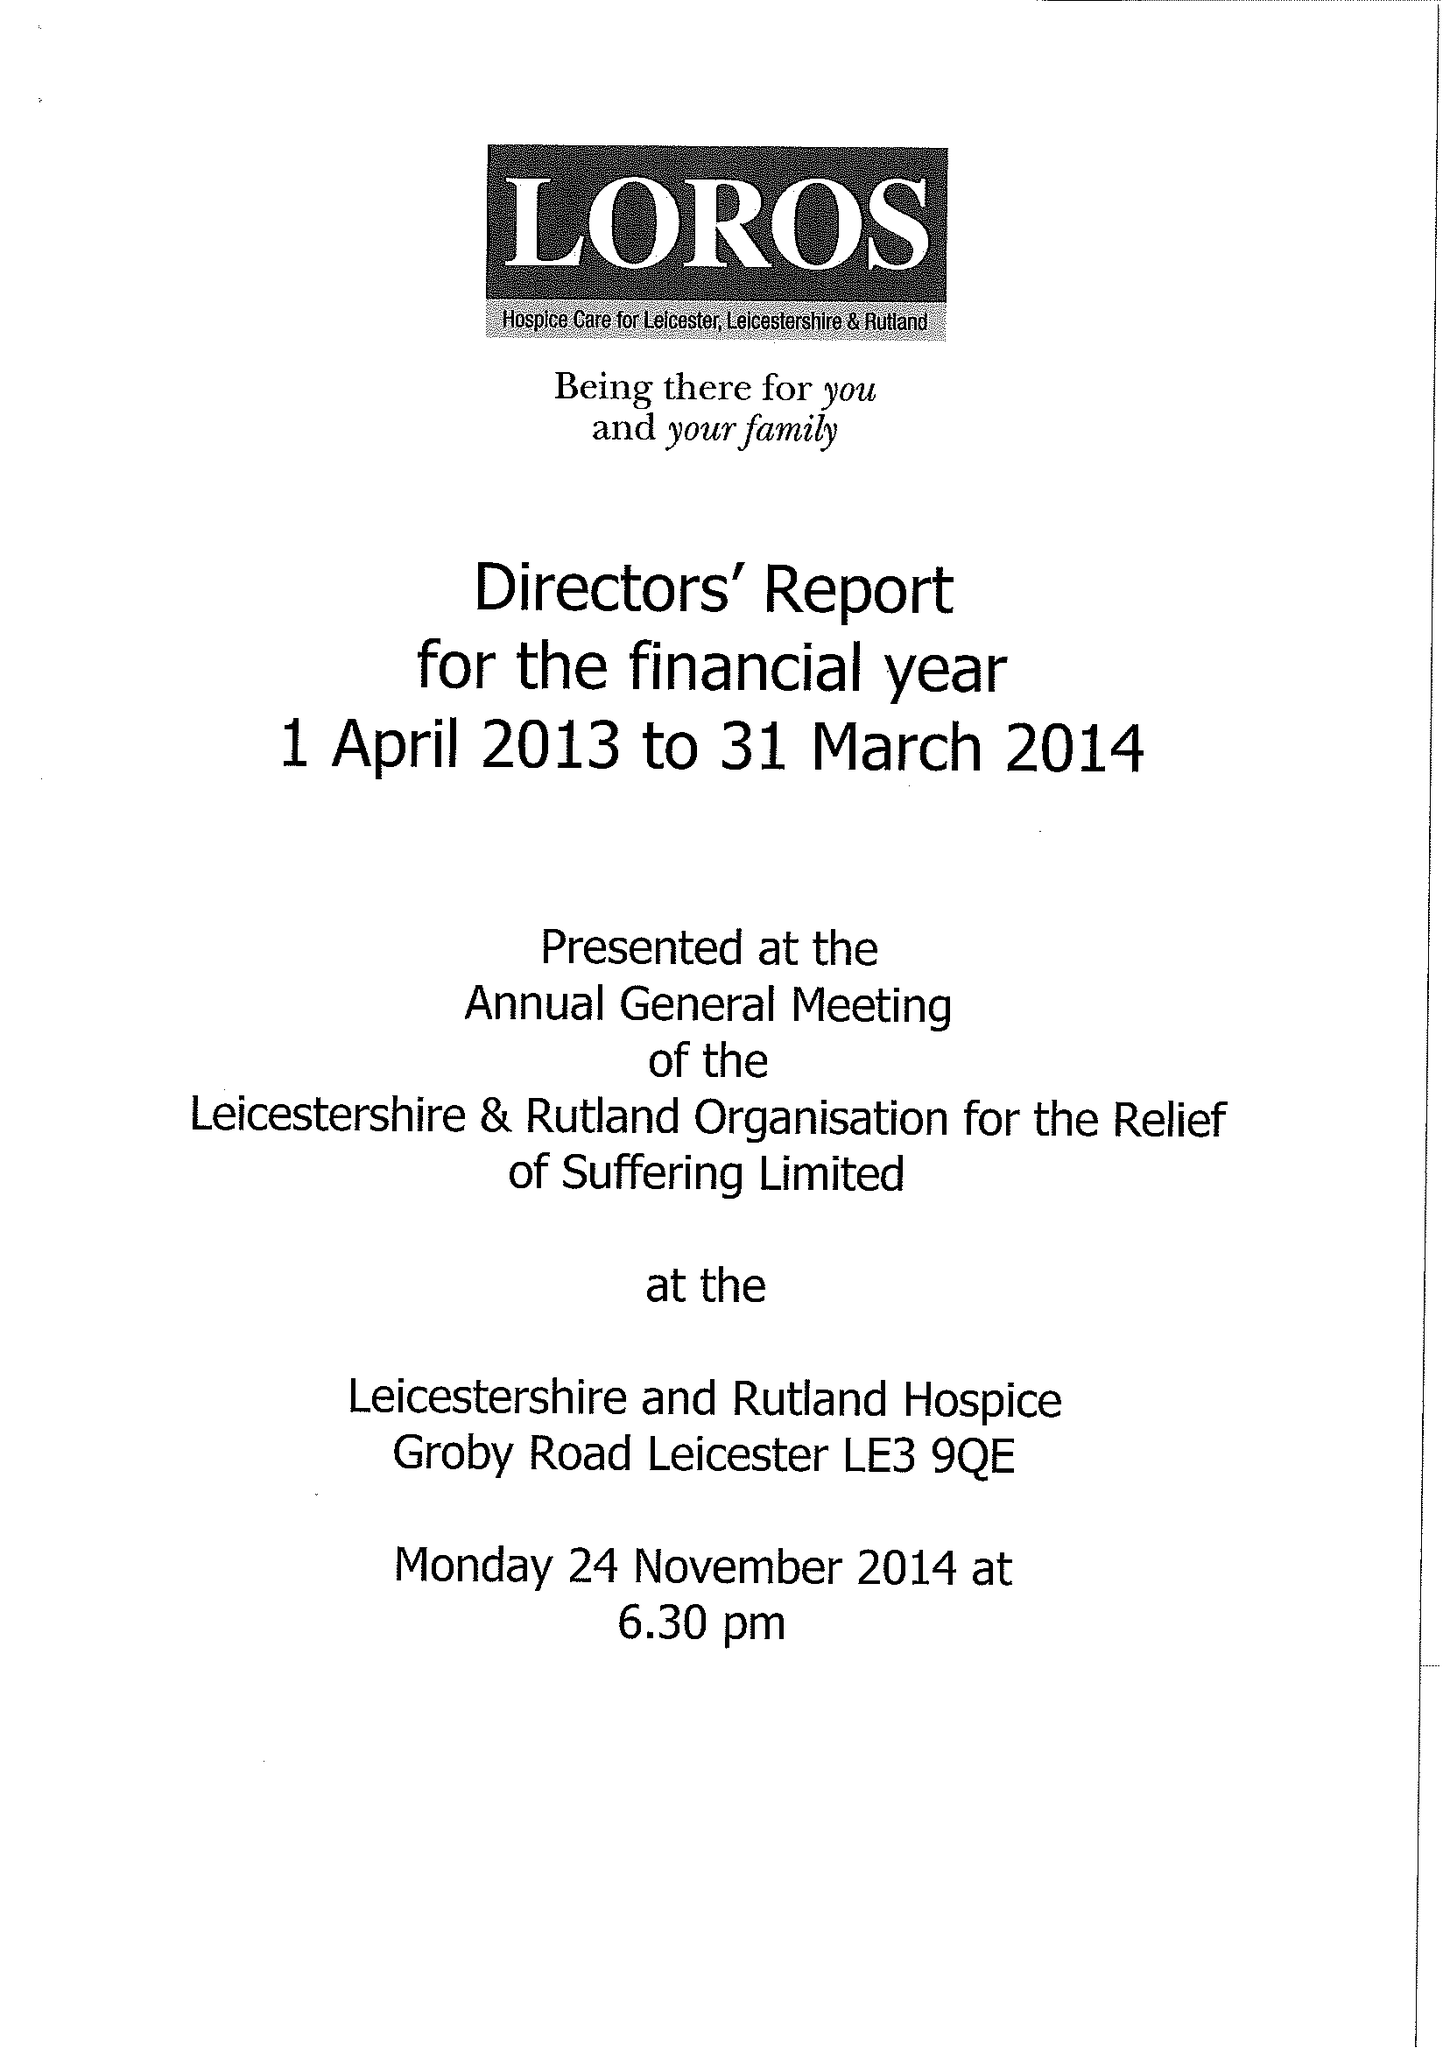What is the value for the income_annually_in_british_pounds?
Answer the question using a single word or phrase. 10971838.00 